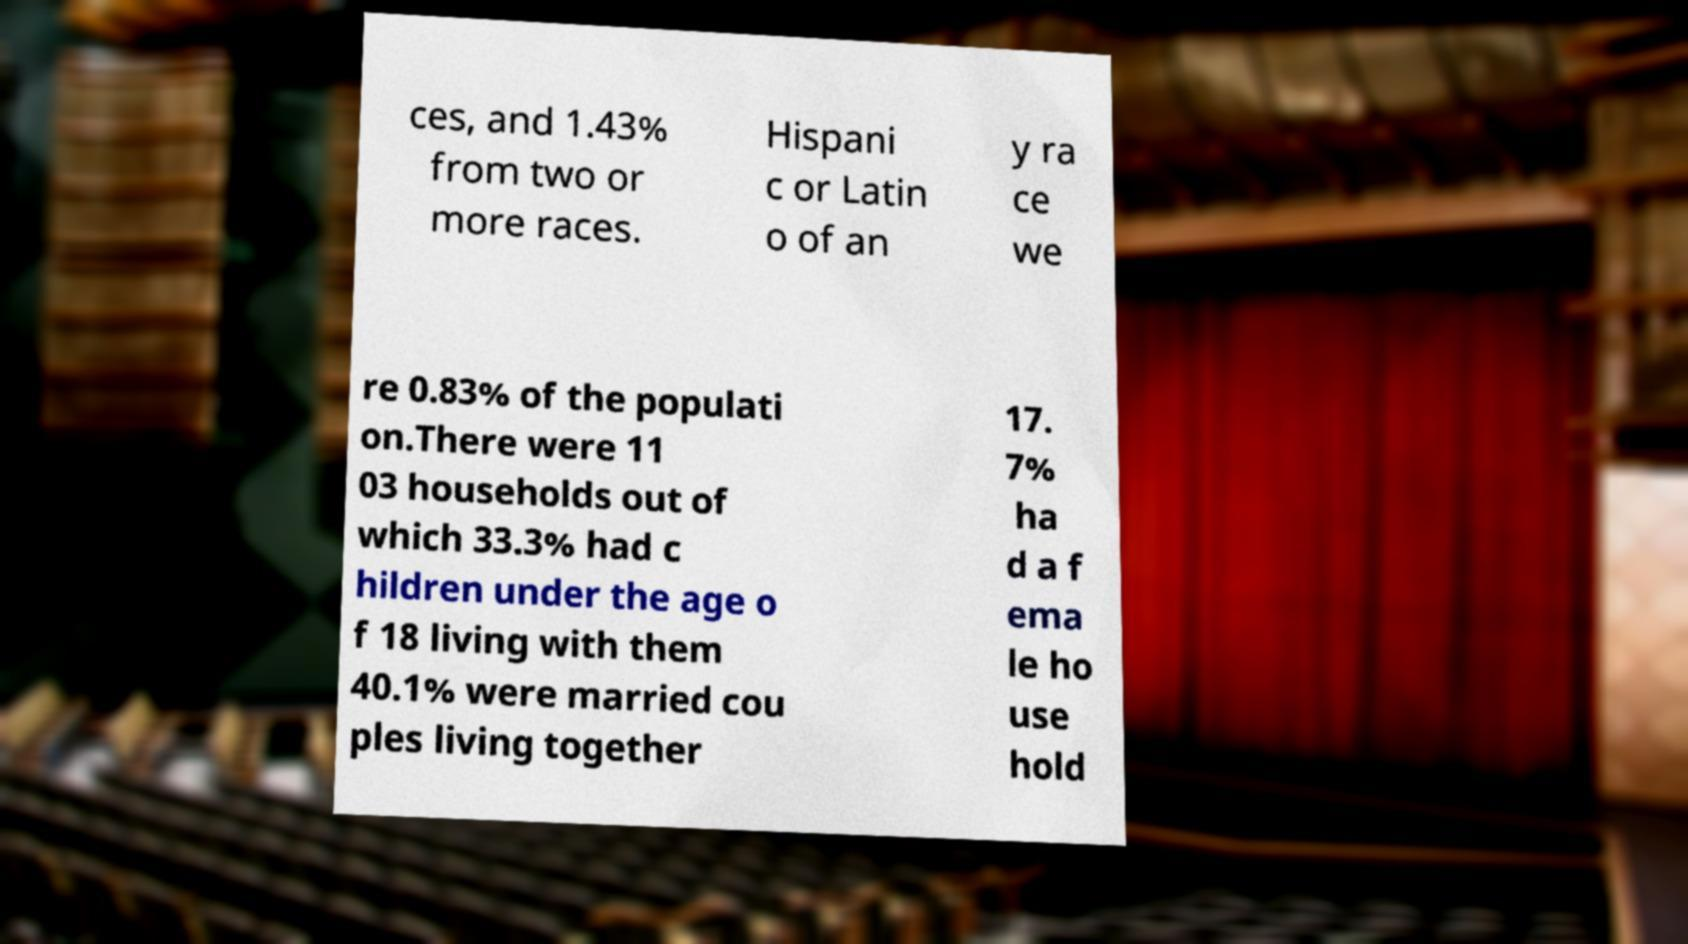Can you accurately transcribe the text from the provided image for me? ces, and 1.43% from two or more races. Hispani c or Latin o of an y ra ce we re 0.83% of the populati on.There were 11 03 households out of which 33.3% had c hildren under the age o f 18 living with them 40.1% were married cou ples living together 17. 7% ha d a f ema le ho use hold 